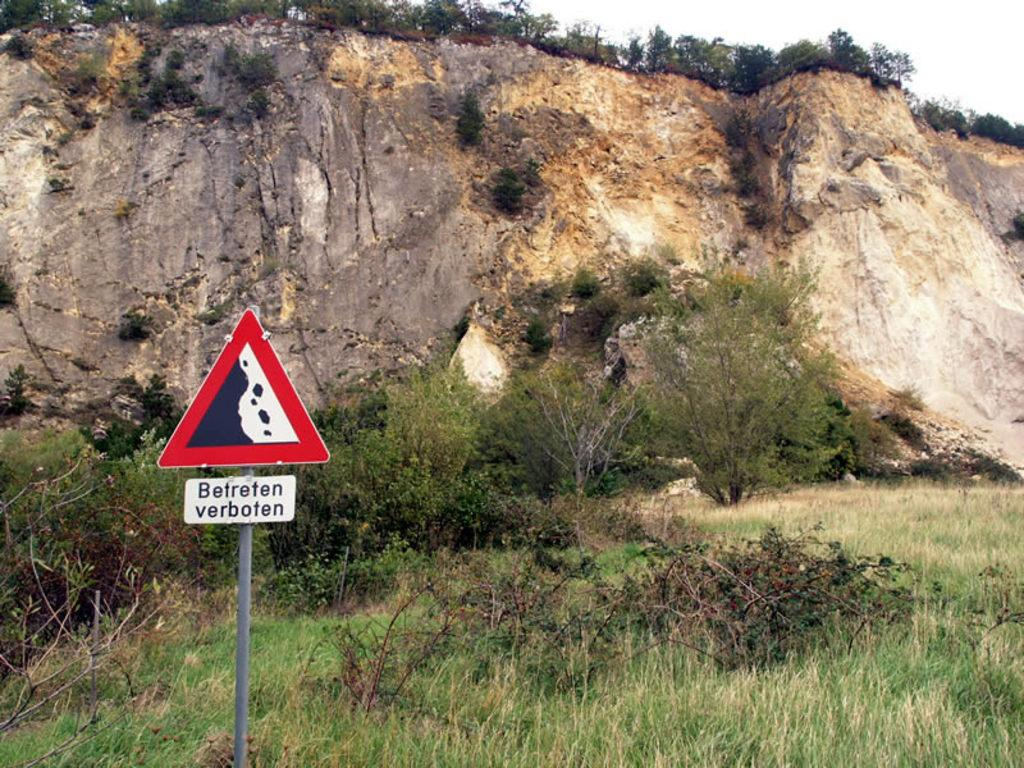<image>
Describe the image concisely. a sign outside of a red black and white triangle labeled 'befreten verboten' 